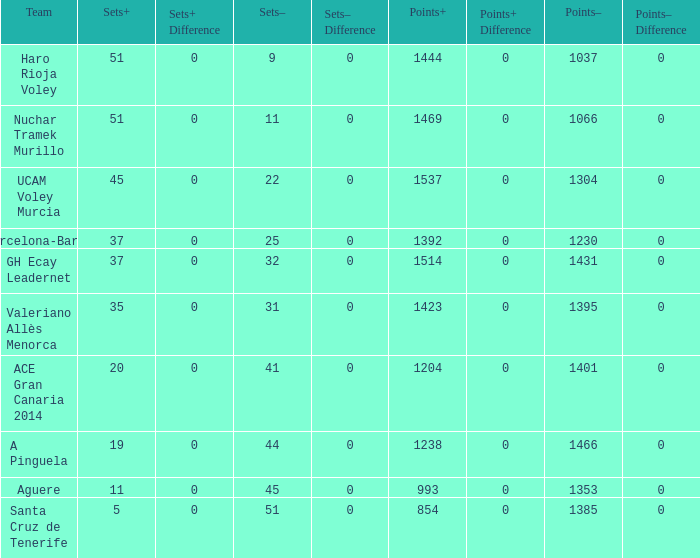What is the highest Sets+ number for Valeriano Allès Menorca when the Sets- number was larger than 31? None. 